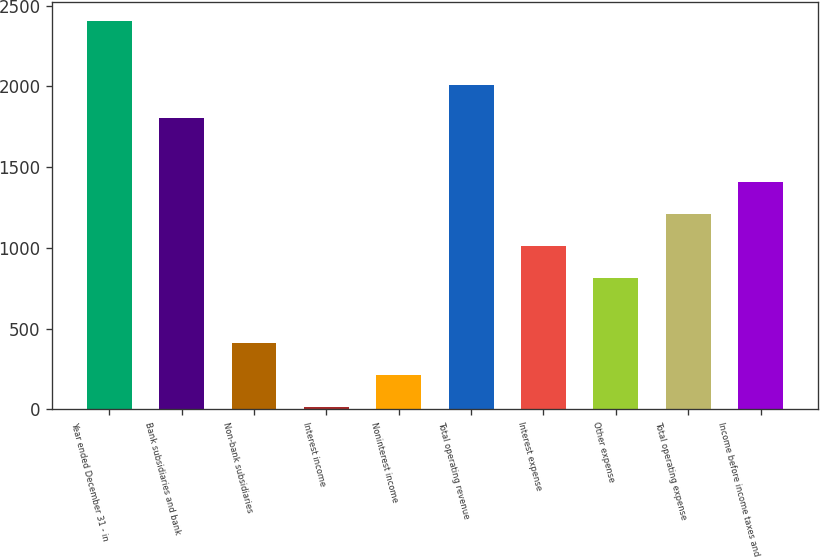Convert chart to OTSL. <chart><loc_0><loc_0><loc_500><loc_500><bar_chart><fcel>Year ended December 31 - in<fcel>Bank subsidiaries and bank<fcel>Non-bank subsidiaries<fcel>Interest income<fcel>Noninterest income<fcel>Total operating revenue<fcel>Interest expense<fcel>Other expense<fcel>Total operating expense<fcel>Income before income taxes and<nl><fcel>2405.4<fcel>1807.8<fcel>413.4<fcel>15<fcel>214.2<fcel>2007<fcel>1011<fcel>811.8<fcel>1210.2<fcel>1409.4<nl></chart> 